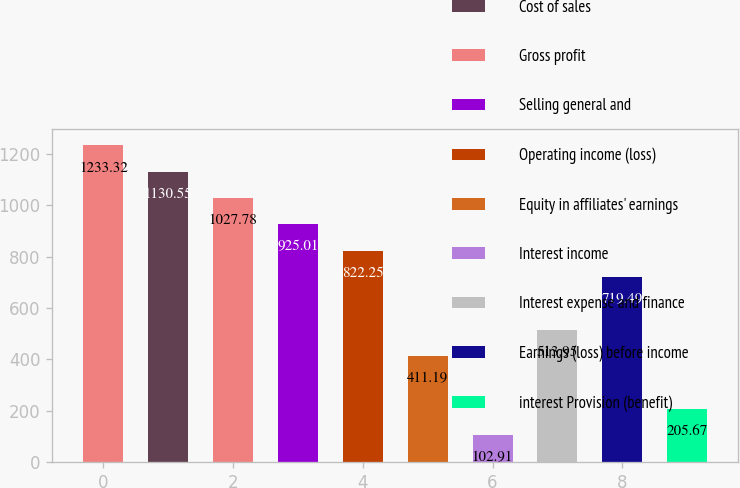<chart> <loc_0><loc_0><loc_500><loc_500><bar_chart><fcel>Net sales<fcel>Cost of sales<fcel>Gross profit<fcel>Selling general and<fcel>Operating income (loss)<fcel>Equity in affiliates' earnings<fcel>Interest income<fcel>Interest expense and finance<fcel>Earnings (loss) before income<fcel>interest Provision (benefit)<nl><fcel>1233.32<fcel>1130.55<fcel>1027.78<fcel>925.01<fcel>822.25<fcel>411.19<fcel>102.91<fcel>513.95<fcel>719.49<fcel>205.67<nl></chart> 